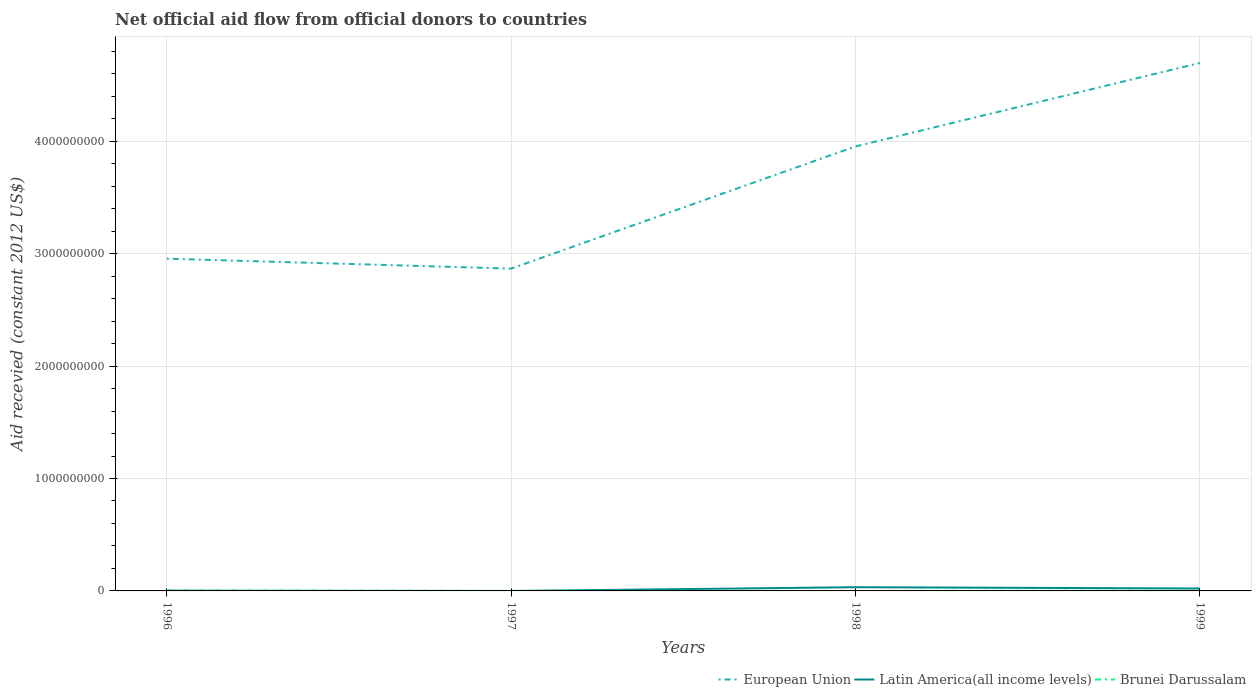How many different coloured lines are there?
Your response must be concise. 3. Is the number of lines equal to the number of legend labels?
Provide a succinct answer. No. Across all years, what is the maximum total aid received in Latin America(all income levels)?
Offer a terse response. 0. What is the total total aid received in European Union in the graph?
Make the answer very short. -1.83e+09. What is the difference between the highest and the second highest total aid received in Latin America(all income levels)?
Make the answer very short. 3.30e+07. What is the difference between the highest and the lowest total aid received in Latin America(all income levels)?
Make the answer very short. 2. Is the total aid received in European Union strictly greater than the total aid received in Latin America(all income levels) over the years?
Keep it short and to the point. No. What is the difference between two consecutive major ticks on the Y-axis?
Provide a succinct answer. 1.00e+09. Does the graph contain any zero values?
Your answer should be compact. Yes. Where does the legend appear in the graph?
Provide a short and direct response. Bottom right. How many legend labels are there?
Offer a very short reply. 3. What is the title of the graph?
Your response must be concise. Net official aid flow from official donors to countries. Does "Lithuania" appear as one of the legend labels in the graph?
Provide a short and direct response. No. What is the label or title of the Y-axis?
Your answer should be compact. Aid recevied (constant 2012 US$). What is the Aid recevied (constant 2012 US$) of European Union in 1996?
Provide a succinct answer. 2.96e+09. What is the Aid recevied (constant 2012 US$) of Latin America(all income levels) in 1996?
Provide a short and direct response. 2.04e+06. What is the Aid recevied (constant 2012 US$) in Brunei Darussalam in 1996?
Ensure brevity in your answer.  3.67e+06. What is the Aid recevied (constant 2012 US$) in European Union in 1997?
Your answer should be compact. 2.87e+09. What is the Aid recevied (constant 2012 US$) in Latin America(all income levels) in 1997?
Offer a terse response. 0. What is the Aid recevied (constant 2012 US$) in European Union in 1998?
Give a very brief answer. 3.95e+09. What is the Aid recevied (constant 2012 US$) of Latin America(all income levels) in 1998?
Offer a very short reply. 3.30e+07. What is the Aid recevied (constant 2012 US$) in European Union in 1999?
Keep it short and to the point. 4.70e+09. What is the Aid recevied (constant 2012 US$) in Latin America(all income levels) in 1999?
Give a very brief answer. 2.15e+07. What is the Aid recevied (constant 2012 US$) of Brunei Darussalam in 1999?
Keep it short and to the point. 2.13e+06. Across all years, what is the maximum Aid recevied (constant 2012 US$) of European Union?
Your answer should be very brief. 4.70e+09. Across all years, what is the maximum Aid recevied (constant 2012 US$) in Latin America(all income levels)?
Provide a succinct answer. 3.30e+07. Across all years, what is the maximum Aid recevied (constant 2012 US$) in Brunei Darussalam?
Provide a short and direct response. 3.67e+06. Across all years, what is the minimum Aid recevied (constant 2012 US$) in European Union?
Keep it short and to the point. 2.87e+09. What is the total Aid recevied (constant 2012 US$) in European Union in the graph?
Provide a succinct answer. 1.45e+1. What is the total Aid recevied (constant 2012 US$) of Latin America(all income levels) in the graph?
Make the answer very short. 5.66e+07. What is the total Aid recevied (constant 2012 US$) in Brunei Darussalam in the graph?
Ensure brevity in your answer.  6.75e+06. What is the difference between the Aid recevied (constant 2012 US$) in European Union in 1996 and that in 1997?
Give a very brief answer. 8.82e+07. What is the difference between the Aid recevied (constant 2012 US$) of Brunei Darussalam in 1996 and that in 1997?
Provide a succinct answer. 3.18e+06. What is the difference between the Aid recevied (constant 2012 US$) in European Union in 1996 and that in 1998?
Make the answer very short. -9.98e+08. What is the difference between the Aid recevied (constant 2012 US$) in Latin America(all income levels) in 1996 and that in 1998?
Make the answer very short. -3.10e+07. What is the difference between the Aid recevied (constant 2012 US$) of Brunei Darussalam in 1996 and that in 1998?
Keep it short and to the point. 3.21e+06. What is the difference between the Aid recevied (constant 2012 US$) in European Union in 1996 and that in 1999?
Give a very brief answer. -1.74e+09. What is the difference between the Aid recevied (constant 2012 US$) of Latin America(all income levels) in 1996 and that in 1999?
Keep it short and to the point. -1.95e+07. What is the difference between the Aid recevied (constant 2012 US$) of Brunei Darussalam in 1996 and that in 1999?
Make the answer very short. 1.54e+06. What is the difference between the Aid recevied (constant 2012 US$) in European Union in 1997 and that in 1998?
Your answer should be very brief. -1.09e+09. What is the difference between the Aid recevied (constant 2012 US$) in European Union in 1997 and that in 1999?
Offer a very short reply. -1.83e+09. What is the difference between the Aid recevied (constant 2012 US$) of Brunei Darussalam in 1997 and that in 1999?
Give a very brief answer. -1.64e+06. What is the difference between the Aid recevied (constant 2012 US$) in European Union in 1998 and that in 1999?
Offer a very short reply. -7.42e+08. What is the difference between the Aid recevied (constant 2012 US$) in Latin America(all income levels) in 1998 and that in 1999?
Give a very brief answer. 1.15e+07. What is the difference between the Aid recevied (constant 2012 US$) in Brunei Darussalam in 1998 and that in 1999?
Provide a succinct answer. -1.67e+06. What is the difference between the Aid recevied (constant 2012 US$) in European Union in 1996 and the Aid recevied (constant 2012 US$) in Brunei Darussalam in 1997?
Make the answer very short. 2.95e+09. What is the difference between the Aid recevied (constant 2012 US$) in Latin America(all income levels) in 1996 and the Aid recevied (constant 2012 US$) in Brunei Darussalam in 1997?
Ensure brevity in your answer.  1.55e+06. What is the difference between the Aid recevied (constant 2012 US$) of European Union in 1996 and the Aid recevied (constant 2012 US$) of Latin America(all income levels) in 1998?
Keep it short and to the point. 2.92e+09. What is the difference between the Aid recevied (constant 2012 US$) of European Union in 1996 and the Aid recevied (constant 2012 US$) of Brunei Darussalam in 1998?
Offer a terse response. 2.95e+09. What is the difference between the Aid recevied (constant 2012 US$) in Latin America(all income levels) in 1996 and the Aid recevied (constant 2012 US$) in Brunei Darussalam in 1998?
Make the answer very short. 1.58e+06. What is the difference between the Aid recevied (constant 2012 US$) of European Union in 1996 and the Aid recevied (constant 2012 US$) of Latin America(all income levels) in 1999?
Make the answer very short. 2.93e+09. What is the difference between the Aid recevied (constant 2012 US$) in European Union in 1996 and the Aid recevied (constant 2012 US$) in Brunei Darussalam in 1999?
Your answer should be very brief. 2.95e+09. What is the difference between the Aid recevied (constant 2012 US$) of European Union in 1997 and the Aid recevied (constant 2012 US$) of Latin America(all income levels) in 1998?
Give a very brief answer. 2.83e+09. What is the difference between the Aid recevied (constant 2012 US$) of European Union in 1997 and the Aid recevied (constant 2012 US$) of Brunei Darussalam in 1998?
Make the answer very short. 2.87e+09. What is the difference between the Aid recevied (constant 2012 US$) in European Union in 1997 and the Aid recevied (constant 2012 US$) in Latin America(all income levels) in 1999?
Offer a terse response. 2.85e+09. What is the difference between the Aid recevied (constant 2012 US$) of European Union in 1997 and the Aid recevied (constant 2012 US$) of Brunei Darussalam in 1999?
Ensure brevity in your answer.  2.86e+09. What is the difference between the Aid recevied (constant 2012 US$) in European Union in 1998 and the Aid recevied (constant 2012 US$) in Latin America(all income levels) in 1999?
Ensure brevity in your answer.  3.93e+09. What is the difference between the Aid recevied (constant 2012 US$) of European Union in 1998 and the Aid recevied (constant 2012 US$) of Brunei Darussalam in 1999?
Provide a short and direct response. 3.95e+09. What is the difference between the Aid recevied (constant 2012 US$) in Latin America(all income levels) in 1998 and the Aid recevied (constant 2012 US$) in Brunei Darussalam in 1999?
Your response must be concise. 3.09e+07. What is the average Aid recevied (constant 2012 US$) of European Union per year?
Offer a very short reply. 3.62e+09. What is the average Aid recevied (constant 2012 US$) in Latin America(all income levels) per year?
Provide a short and direct response. 1.41e+07. What is the average Aid recevied (constant 2012 US$) of Brunei Darussalam per year?
Your answer should be very brief. 1.69e+06. In the year 1996, what is the difference between the Aid recevied (constant 2012 US$) of European Union and Aid recevied (constant 2012 US$) of Latin America(all income levels)?
Your answer should be very brief. 2.95e+09. In the year 1996, what is the difference between the Aid recevied (constant 2012 US$) in European Union and Aid recevied (constant 2012 US$) in Brunei Darussalam?
Ensure brevity in your answer.  2.95e+09. In the year 1996, what is the difference between the Aid recevied (constant 2012 US$) in Latin America(all income levels) and Aid recevied (constant 2012 US$) in Brunei Darussalam?
Your answer should be very brief. -1.63e+06. In the year 1997, what is the difference between the Aid recevied (constant 2012 US$) in European Union and Aid recevied (constant 2012 US$) in Brunei Darussalam?
Your answer should be very brief. 2.87e+09. In the year 1998, what is the difference between the Aid recevied (constant 2012 US$) of European Union and Aid recevied (constant 2012 US$) of Latin America(all income levels)?
Your answer should be compact. 3.92e+09. In the year 1998, what is the difference between the Aid recevied (constant 2012 US$) in European Union and Aid recevied (constant 2012 US$) in Brunei Darussalam?
Give a very brief answer. 3.95e+09. In the year 1998, what is the difference between the Aid recevied (constant 2012 US$) of Latin America(all income levels) and Aid recevied (constant 2012 US$) of Brunei Darussalam?
Offer a terse response. 3.26e+07. In the year 1999, what is the difference between the Aid recevied (constant 2012 US$) in European Union and Aid recevied (constant 2012 US$) in Latin America(all income levels)?
Your answer should be compact. 4.67e+09. In the year 1999, what is the difference between the Aid recevied (constant 2012 US$) of European Union and Aid recevied (constant 2012 US$) of Brunei Darussalam?
Give a very brief answer. 4.69e+09. In the year 1999, what is the difference between the Aid recevied (constant 2012 US$) in Latin America(all income levels) and Aid recevied (constant 2012 US$) in Brunei Darussalam?
Your answer should be compact. 1.94e+07. What is the ratio of the Aid recevied (constant 2012 US$) in European Union in 1996 to that in 1997?
Provide a succinct answer. 1.03. What is the ratio of the Aid recevied (constant 2012 US$) of Brunei Darussalam in 1996 to that in 1997?
Offer a terse response. 7.49. What is the ratio of the Aid recevied (constant 2012 US$) in European Union in 1996 to that in 1998?
Offer a terse response. 0.75. What is the ratio of the Aid recevied (constant 2012 US$) of Latin America(all income levels) in 1996 to that in 1998?
Give a very brief answer. 0.06. What is the ratio of the Aid recevied (constant 2012 US$) in Brunei Darussalam in 1996 to that in 1998?
Give a very brief answer. 7.98. What is the ratio of the Aid recevied (constant 2012 US$) in European Union in 1996 to that in 1999?
Offer a very short reply. 0.63. What is the ratio of the Aid recevied (constant 2012 US$) in Latin America(all income levels) in 1996 to that in 1999?
Ensure brevity in your answer.  0.09. What is the ratio of the Aid recevied (constant 2012 US$) in Brunei Darussalam in 1996 to that in 1999?
Your answer should be very brief. 1.72. What is the ratio of the Aid recevied (constant 2012 US$) of European Union in 1997 to that in 1998?
Your answer should be compact. 0.73. What is the ratio of the Aid recevied (constant 2012 US$) in Brunei Darussalam in 1997 to that in 1998?
Ensure brevity in your answer.  1.07. What is the ratio of the Aid recevied (constant 2012 US$) in European Union in 1997 to that in 1999?
Your answer should be very brief. 0.61. What is the ratio of the Aid recevied (constant 2012 US$) of Brunei Darussalam in 1997 to that in 1999?
Offer a very short reply. 0.23. What is the ratio of the Aid recevied (constant 2012 US$) of European Union in 1998 to that in 1999?
Offer a very short reply. 0.84. What is the ratio of the Aid recevied (constant 2012 US$) in Latin America(all income levels) in 1998 to that in 1999?
Your response must be concise. 1.54. What is the ratio of the Aid recevied (constant 2012 US$) of Brunei Darussalam in 1998 to that in 1999?
Provide a short and direct response. 0.22. What is the difference between the highest and the second highest Aid recevied (constant 2012 US$) in European Union?
Make the answer very short. 7.42e+08. What is the difference between the highest and the second highest Aid recevied (constant 2012 US$) of Latin America(all income levels)?
Make the answer very short. 1.15e+07. What is the difference between the highest and the second highest Aid recevied (constant 2012 US$) of Brunei Darussalam?
Keep it short and to the point. 1.54e+06. What is the difference between the highest and the lowest Aid recevied (constant 2012 US$) in European Union?
Offer a very short reply. 1.83e+09. What is the difference between the highest and the lowest Aid recevied (constant 2012 US$) in Latin America(all income levels)?
Make the answer very short. 3.30e+07. What is the difference between the highest and the lowest Aid recevied (constant 2012 US$) in Brunei Darussalam?
Offer a very short reply. 3.21e+06. 